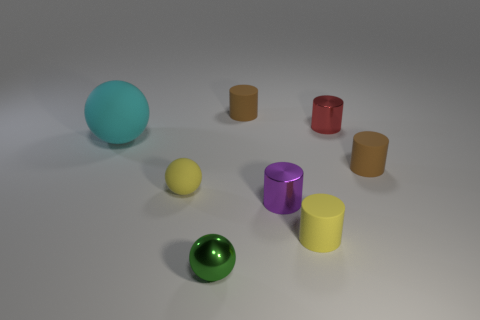Are there the same number of tiny red objects that are in front of the big cyan rubber object and tiny yellow matte balls that are to the right of the green thing?
Ensure brevity in your answer.  Yes. There is a small rubber object that is left of the small brown rubber cylinder behind the big cyan object; what is its shape?
Keep it short and to the point. Sphere. What material is the big thing that is the same shape as the tiny green metal object?
Keep it short and to the point. Rubber. There is another shiny cylinder that is the same size as the purple cylinder; what is its color?
Provide a succinct answer. Red. Are there the same number of cylinders behind the shiny ball and small cylinders?
Offer a terse response. Yes. There is a small rubber object that is left of the brown thing behind the cyan thing; what is its color?
Provide a succinct answer. Yellow. There is a rubber sphere that is behind the rubber thing that is to the right of the tiny red metal thing; how big is it?
Your response must be concise. Large. What number of other things are the same size as the green ball?
Your answer should be very brief. 6. The small metallic cylinder behind the brown rubber thing in front of the small brown thing to the left of the small purple metallic object is what color?
Give a very brief answer. Red. What number of other objects are the same shape as the large object?
Your answer should be very brief. 2. 